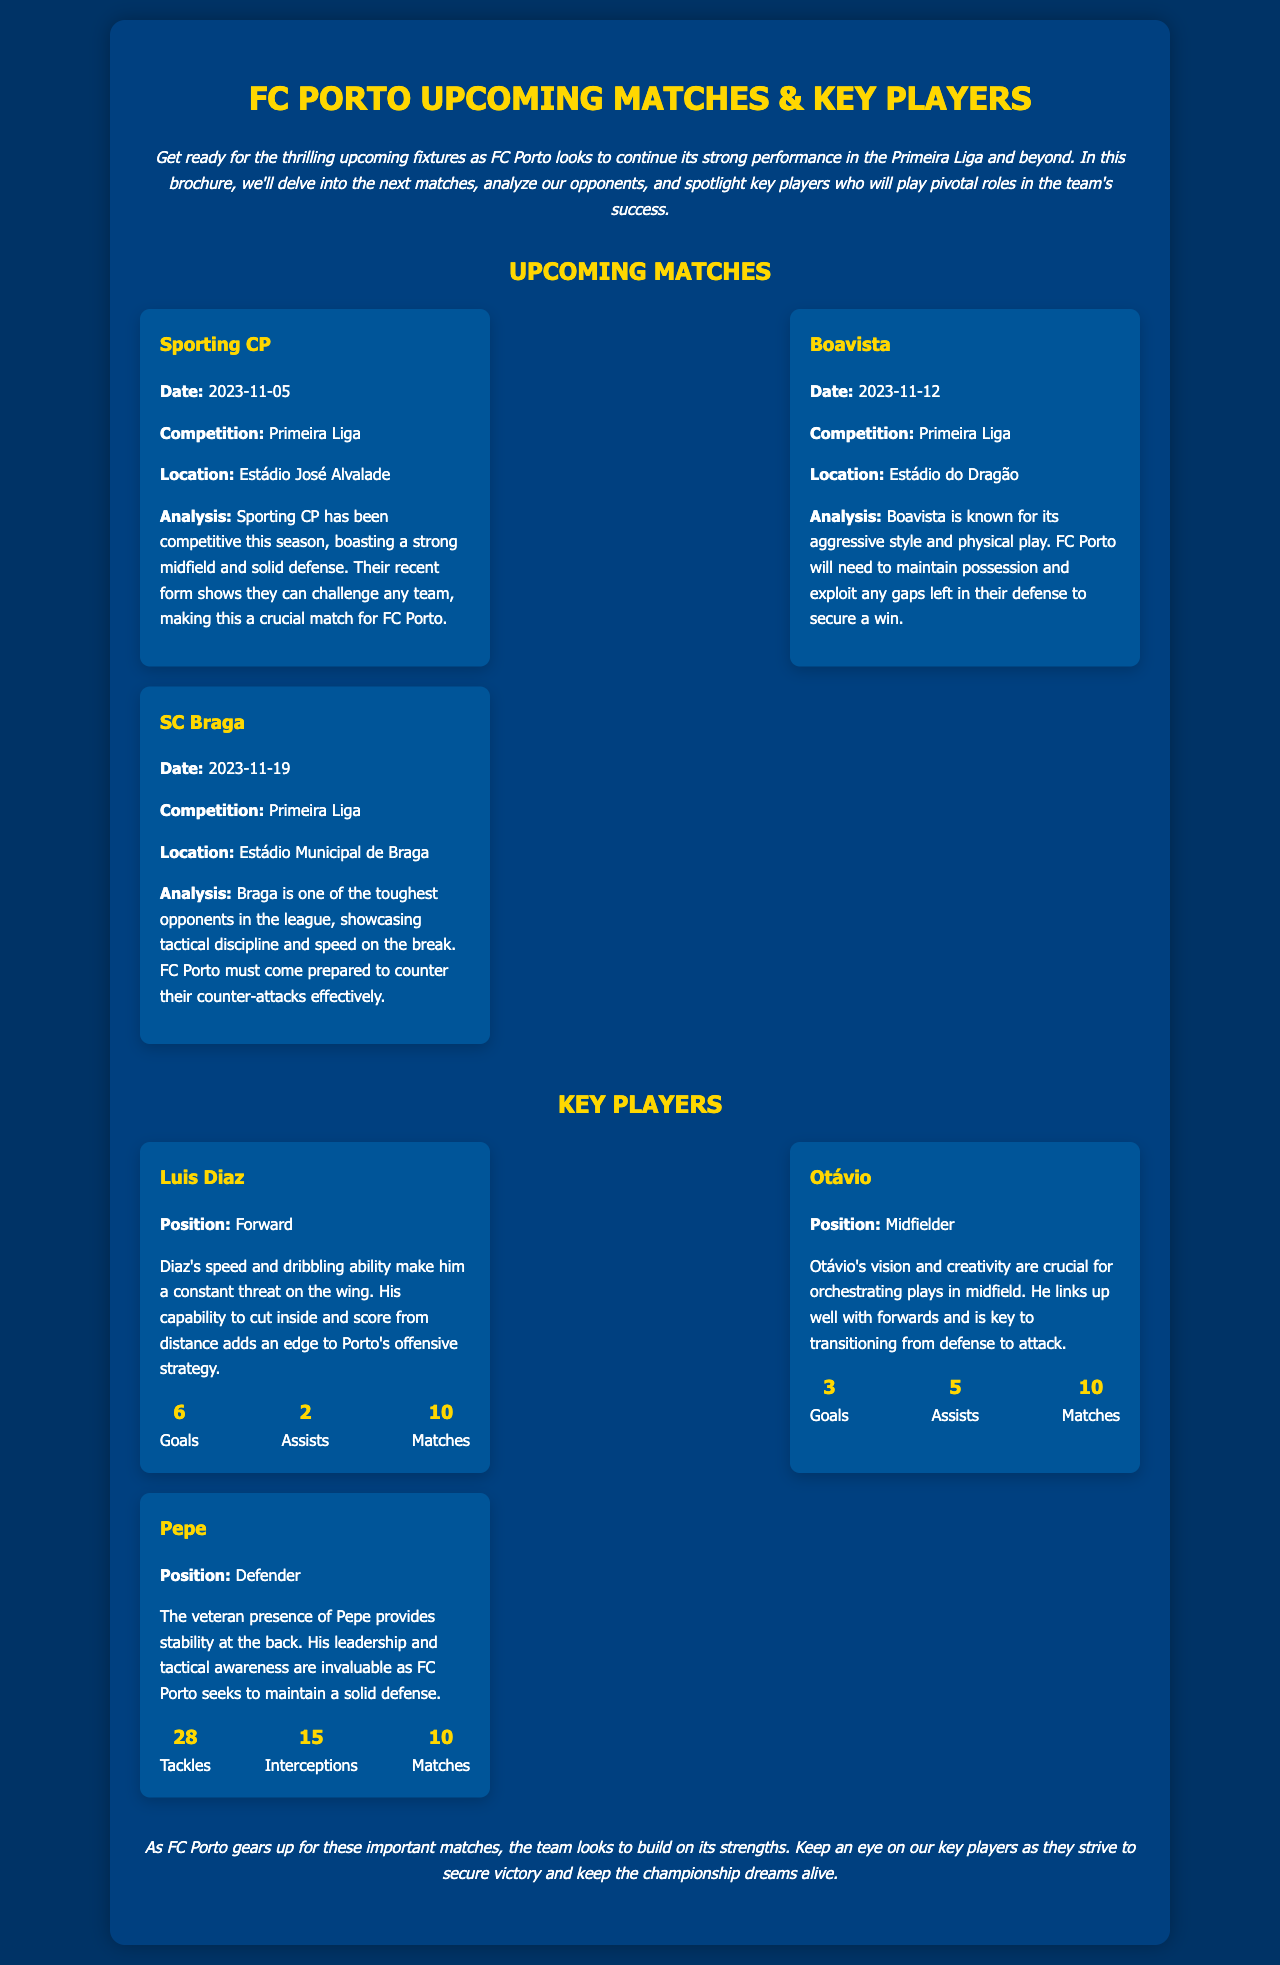what is the date of the match against Sporting CP? The date of the match against Sporting CP is mentioned in the document.
Answer: 2023-11-05 what is the location of the match against Boavista? The location for the match against Boavista is specified in the document.
Answer: Estádio do Dragão who is the key player spotlighted for the forward position? The document highlights Luis Diaz as a key player in the forward position.
Answer: Luis Diaz how many goals has Otávio scored this season? The document provides specific statistics for Otávio, including the number of goals scored.
Answer: 3 what is the primary strength of Sporting CP according to the analysis? The document describes Sporting CP's capabilities in the analysis section.
Answer: Strong midfield and solid defense what is Pepe's notable statistic related to tackles? The document lists Pepe's notable statistics, including tackles.
Answer: 28 which match is considered crucial for FC Porto? The document indicates the importance of a specific match through the opponent’s analysis.
Answer: Sporting CP how many assists does Luis Diaz have so far? The document lists the statistic of assists for Luis Diaz.
Answer: 2 